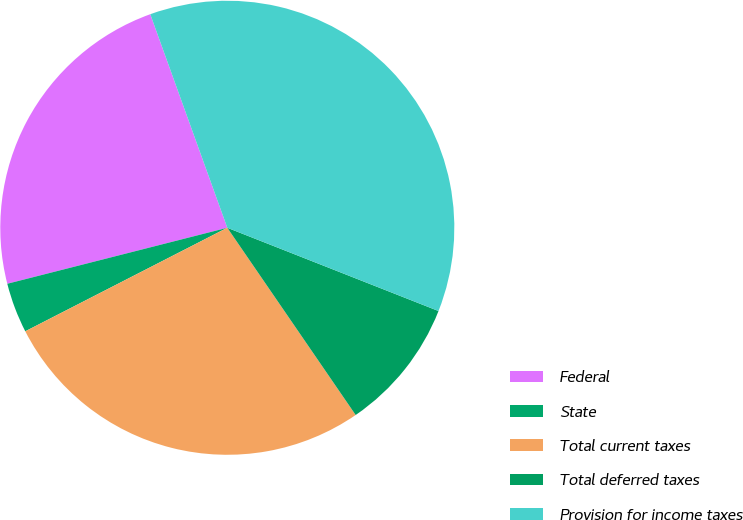Convert chart. <chart><loc_0><loc_0><loc_500><loc_500><pie_chart><fcel>Federal<fcel>State<fcel>Total current taxes<fcel>Total deferred taxes<fcel>Provision for income taxes<nl><fcel>23.46%<fcel>3.57%<fcel>27.03%<fcel>9.46%<fcel>36.49%<nl></chart> 